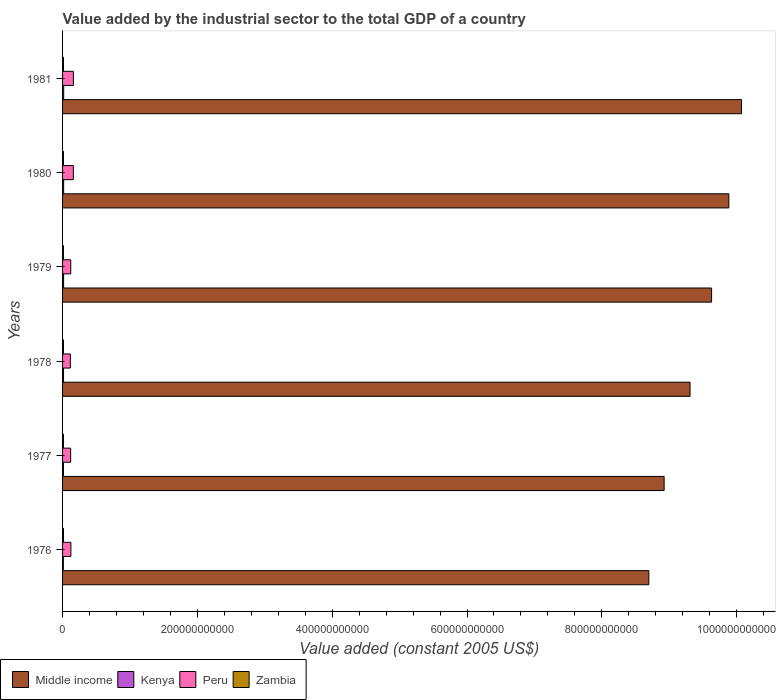How many groups of bars are there?
Ensure brevity in your answer.  6. Are the number of bars on each tick of the Y-axis equal?
Your response must be concise. Yes. What is the label of the 3rd group of bars from the top?
Your answer should be very brief. 1979. In how many cases, is the number of bars for a given year not equal to the number of legend labels?
Provide a short and direct response. 0. What is the value added by the industrial sector in Middle income in 1976?
Ensure brevity in your answer.  8.70e+11. Across all years, what is the maximum value added by the industrial sector in Kenya?
Ensure brevity in your answer.  1.66e+09. Across all years, what is the minimum value added by the industrial sector in Peru?
Give a very brief answer. 1.15e+1. In which year was the value added by the industrial sector in Kenya maximum?
Offer a very short reply. 1981. In which year was the value added by the industrial sector in Peru minimum?
Your answer should be very brief. 1978. What is the total value added by the industrial sector in Kenya in the graph?
Give a very brief answer. 8.73e+09. What is the difference between the value added by the industrial sector in Kenya in 1976 and that in 1981?
Your answer should be compact. -4.87e+08. What is the difference between the value added by the industrial sector in Middle income in 1980 and the value added by the industrial sector in Zambia in 1977?
Provide a succinct answer. 9.87e+11. What is the average value added by the industrial sector in Zambia per year?
Keep it short and to the point. 1.33e+09. In the year 1977, what is the difference between the value added by the industrial sector in Kenya and value added by the industrial sector in Middle income?
Provide a short and direct response. -8.91e+11. In how many years, is the value added by the industrial sector in Middle income greater than 80000000000 US$?
Ensure brevity in your answer.  6. What is the ratio of the value added by the industrial sector in Kenya in 1977 to that in 1981?
Keep it short and to the point. 0.8. What is the difference between the highest and the second highest value added by the industrial sector in Peru?
Provide a succinct answer. 1.73e+07. What is the difference between the highest and the lowest value added by the industrial sector in Peru?
Provide a short and direct response. 4.49e+09. Is the sum of the value added by the industrial sector in Middle income in 1978 and 1980 greater than the maximum value added by the industrial sector in Peru across all years?
Keep it short and to the point. Yes. Is it the case that in every year, the sum of the value added by the industrial sector in Peru and value added by the industrial sector in Zambia is greater than the sum of value added by the industrial sector in Kenya and value added by the industrial sector in Middle income?
Your answer should be very brief. No. What does the 3rd bar from the bottom in 1980 represents?
Give a very brief answer. Peru. Is it the case that in every year, the sum of the value added by the industrial sector in Kenya and value added by the industrial sector in Zambia is greater than the value added by the industrial sector in Middle income?
Keep it short and to the point. No. How many bars are there?
Your response must be concise. 24. Are all the bars in the graph horizontal?
Make the answer very short. Yes. What is the difference between two consecutive major ticks on the X-axis?
Ensure brevity in your answer.  2.00e+11. Are the values on the major ticks of X-axis written in scientific E-notation?
Provide a succinct answer. No. Does the graph contain grids?
Offer a terse response. No. How many legend labels are there?
Make the answer very short. 4. What is the title of the graph?
Your answer should be very brief. Value added by the industrial sector to the total GDP of a country. What is the label or title of the X-axis?
Provide a succinct answer. Value added (constant 2005 US$). What is the label or title of the Y-axis?
Provide a succinct answer. Years. What is the Value added (constant 2005 US$) of Middle income in 1976?
Offer a terse response. 8.70e+11. What is the Value added (constant 2005 US$) of Kenya in 1976?
Provide a succinct answer. 1.17e+09. What is the Value added (constant 2005 US$) of Peru in 1976?
Offer a terse response. 1.24e+1. What is the Value added (constant 2005 US$) of Zambia in 1976?
Provide a succinct answer. 1.38e+09. What is the Value added (constant 2005 US$) in Middle income in 1977?
Offer a very short reply. 8.92e+11. What is the Value added (constant 2005 US$) of Kenya in 1977?
Make the answer very short. 1.32e+09. What is the Value added (constant 2005 US$) of Peru in 1977?
Keep it short and to the point. 1.20e+1. What is the Value added (constant 2005 US$) of Zambia in 1977?
Offer a terse response. 1.29e+09. What is the Value added (constant 2005 US$) in Middle income in 1978?
Ensure brevity in your answer.  9.31e+11. What is the Value added (constant 2005 US$) in Kenya in 1978?
Your answer should be compact. 1.46e+09. What is the Value added (constant 2005 US$) of Peru in 1978?
Provide a succinct answer. 1.15e+1. What is the Value added (constant 2005 US$) of Zambia in 1978?
Make the answer very short. 1.34e+09. What is the Value added (constant 2005 US$) in Middle income in 1979?
Offer a very short reply. 9.63e+11. What is the Value added (constant 2005 US$) of Kenya in 1979?
Offer a terse response. 1.52e+09. What is the Value added (constant 2005 US$) of Peru in 1979?
Give a very brief answer. 1.21e+1. What is the Value added (constant 2005 US$) of Zambia in 1979?
Offer a terse response. 1.28e+09. What is the Value added (constant 2005 US$) of Middle income in 1980?
Ensure brevity in your answer.  9.88e+11. What is the Value added (constant 2005 US$) of Kenya in 1980?
Make the answer very short. 1.60e+09. What is the Value added (constant 2005 US$) in Peru in 1980?
Provide a succinct answer. 1.60e+1. What is the Value added (constant 2005 US$) in Zambia in 1980?
Ensure brevity in your answer.  1.30e+09. What is the Value added (constant 2005 US$) in Middle income in 1981?
Ensure brevity in your answer.  1.01e+12. What is the Value added (constant 2005 US$) in Kenya in 1981?
Your answer should be compact. 1.66e+09. What is the Value added (constant 2005 US$) in Peru in 1981?
Make the answer very short. 1.60e+1. What is the Value added (constant 2005 US$) of Zambia in 1981?
Provide a succinct answer. 1.37e+09. Across all years, what is the maximum Value added (constant 2005 US$) of Middle income?
Keep it short and to the point. 1.01e+12. Across all years, what is the maximum Value added (constant 2005 US$) of Kenya?
Provide a succinct answer. 1.66e+09. Across all years, what is the maximum Value added (constant 2005 US$) of Peru?
Give a very brief answer. 1.60e+1. Across all years, what is the maximum Value added (constant 2005 US$) of Zambia?
Your answer should be compact. 1.38e+09. Across all years, what is the minimum Value added (constant 2005 US$) of Middle income?
Your answer should be compact. 8.70e+11. Across all years, what is the minimum Value added (constant 2005 US$) in Kenya?
Keep it short and to the point. 1.17e+09. Across all years, what is the minimum Value added (constant 2005 US$) of Peru?
Ensure brevity in your answer.  1.15e+1. Across all years, what is the minimum Value added (constant 2005 US$) of Zambia?
Provide a short and direct response. 1.28e+09. What is the total Value added (constant 2005 US$) of Middle income in the graph?
Offer a very short reply. 5.65e+12. What is the total Value added (constant 2005 US$) in Kenya in the graph?
Keep it short and to the point. 8.73e+09. What is the total Value added (constant 2005 US$) in Peru in the graph?
Make the answer very short. 8.01e+1. What is the total Value added (constant 2005 US$) of Zambia in the graph?
Keep it short and to the point. 7.97e+09. What is the difference between the Value added (constant 2005 US$) of Middle income in 1976 and that in 1977?
Offer a terse response. -2.27e+1. What is the difference between the Value added (constant 2005 US$) in Kenya in 1976 and that in 1977?
Your response must be concise. -1.51e+08. What is the difference between the Value added (constant 2005 US$) of Peru in 1976 and that in 1977?
Provide a succinct answer. 3.55e+08. What is the difference between the Value added (constant 2005 US$) of Zambia in 1976 and that in 1977?
Your answer should be very brief. 9.32e+07. What is the difference between the Value added (constant 2005 US$) in Middle income in 1976 and that in 1978?
Make the answer very short. -6.11e+1. What is the difference between the Value added (constant 2005 US$) of Kenya in 1976 and that in 1978?
Make the answer very short. -2.91e+08. What is the difference between the Value added (constant 2005 US$) in Peru in 1976 and that in 1978?
Ensure brevity in your answer.  8.14e+08. What is the difference between the Value added (constant 2005 US$) of Zambia in 1976 and that in 1978?
Ensure brevity in your answer.  3.74e+07. What is the difference between the Value added (constant 2005 US$) in Middle income in 1976 and that in 1979?
Provide a short and direct response. -9.31e+1. What is the difference between the Value added (constant 2005 US$) in Kenya in 1976 and that in 1979?
Ensure brevity in your answer.  -3.43e+08. What is the difference between the Value added (constant 2005 US$) in Peru in 1976 and that in 1979?
Provide a succinct answer. 2.24e+08. What is the difference between the Value added (constant 2005 US$) in Zambia in 1976 and that in 1979?
Give a very brief answer. 1.06e+08. What is the difference between the Value added (constant 2005 US$) in Middle income in 1976 and that in 1980?
Your answer should be compact. -1.19e+11. What is the difference between the Value added (constant 2005 US$) of Kenya in 1976 and that in 1980?
Ensure brevity in your answer.  -4.23e+08. What is the difference between the Value added (constant 2005 US$) of Peru in 1976 and that in 1980?
Your answer should be very brief. -3.66e+09. What is the difference between the Value added (constant 2005 US$) in Zambia in 1976 and that in 1980?
Offer a terse response. 7.72e+07. What is the difference between the Value added (constant 2005 US$) of Middle income in 1976 and that in 1981?
Offer a very short reply. -1.38e+11. What is the difference between the Value added (constant 2005 US$) of Kenya in 1976 and that in 1981?
Your answer should be very brief. -4.87e+08. What is the difference between the Value added (constant 2005 US$) of Peru in 1976 and that in 1981?
Give a very brief answer. -3.67e+09. What is the difference between the Value added (constant 2005 US$) in Zambia in 1976 and that in 1981?
Your answer should be compact. 1.24e+07. What is the difference between the Value added (constant 2005 US$) in Middle income in 1977 and that in 1978?
Make the answer very short. -3.84e+1. What is the difference between the Value added (constant 2005 US$) of Kenya in 1977 and that in 1978?
Ensure brevity in your answer.  -1.40e+08. What is the difference between the Value added (constant 2005 US$) of Peru in 1977 and that in 1978?
Your answer should be very brief. 4.59e+08. What is the difference between the Value added (constant 2005 US$) of Zambia in 1977 and that in 1978?
Your answer should be very brief. -5.58e+07. What is the difference between the Value added (constant 2005 US$) of Middle income in 1977 and that in 1979?
Provide a short and direct response. -7.04e+1. What is the difference between the Value added (constant 2005 US$) in Kenya in 1977 and that in 1979?
Your answer should be very brief. -1.92e+08. What is the difference between the Value added (constant 2005 US$) of Peru in 1977 and that in 1979?
Provide a short and direct response. -1.31e+08. What is the difference between the Value added (constant 2005 US$) of Zambia in 1977 and that in 1979?
Keep it short and to the point. 1.31e+07. What is the difference between the Value added (constant 2005 US$) in Middle income in 1977 and that in 1980?
Offer a very short reply. -9.60e+1. What is the difference between the Value added (constant 2005 US$) in Kenya in 1977 and that in 1980?
Provide a succinct answer. -2.73e+08. What is the difference between the Value added (constant 2005 US$) in Peru in 1977 and that in 1980?
Offer a terse response. -4.01e+09. What is the difference between the Value added (constant 2005 US$) in Zambia in 1977 and that in 1980?
Keep it short and to the point. -1.60e+07. What is the difference between the Value added (constant 2005 US$) of Middle income in 1977 and that in 1981?
Provide a short and direct response. -1.15e+11. What is the difference between the Value added (constant 2005 US$) in Kenya in 1977 and that in 1981?
Your response must be concise. -3.36e+08. What is the difference between the Value added (constant 2005 US$) in Peru in 1977 and that in 1981?
Provide a short and direct response. -4.03e+09. What is the difference between the Value added (constant 2005 US$) of Zambia in 1977 and that in 1981?
Keep it short and to the point. -8.08e+07. What is the difference between the Value added (constant 2005 US$) in Middle income in 1978 and that in 1979?
Make the answer very short. -3.20e+1. What is the difference between the Value added (constant 2005 US$) in Kenya in 1978 and that in 1979?
Offer a very short reply. -5.17e+07. What is the difference between the Value added (constant 2005 US$) in Peru in 1978 and that in 1979?
Offer a terse response. -5.89e+08. What is the difference between the Value added (constant 2005 US$) of Zambia in 1978 and that in 1979?
Provide a succinct answer. 6.89e+07. What is the difference between the Value added (constant 2005 US$) in Middle income in 1978 and that in 1980?
Ensure brevity in your answer.  -5.75e+1. What is the difference between the Value added (constant 2005 US$) in Kenya in 1978 and that in 1980?
Offer a very short reply. -1.33e+08. What is the difference between the Value added (constant 2005 US$) in Peru in 1978 and that in 1980?
Your answer should be very brief. -4.47e+09. What is the difference between the Value added (constant 2005 US$) in Zambia in 1978 and that in 1980?
Keep it short and to the point. 3.98e+07. What is the difference between the Value added (constant 2005 US$) in Middle income in 1978 and that in 1981?
Keep it short and to the point. -7.64e+1. What is the difference between the Value added (constant 2005 US$) of Kenya in 1978 and that in 1981?
Your answer should be very brief. -1.96e+08. What is the difference between the Value added (constant 2005 US$) in Peru in 1978 and that in 1981?
Keep it short and to the point. -4.49e+09. What is the difference between the Value added (constant 2005 US$) of Zambia in 1978 and that in 1981?
Your answer should be very brief. -2.50e+07. What is the difference between the Value added (constant 2005 US$) in Middle income in 1979 and that in 1980?
Provide a short and direct response. -2.56e+1. What is the difference between the Value added (constant 2005 US$) of Kenya in 1979 and that in 1980?
Provide a succinct answer. -8.08e+07. What is the difference between the Value added (constant 2005 US$) in Peru in 1979 and that in 1980?
Ensure brevity in your answer.  -3.88e+09. What is the difference between the Value added (constant 2005 US$) of Zambia in 1979 and that in 1980?
Offer a terse response. -2.91e+07. What is the difference between the Value added (constant 2005 US$) in Middle income in 1979 and that in 1981?
Give a very brief answer. -4.44e+1. What is the difference between the Value added (constant 2005 US$) in Kenya in 1979 and that in 1981?
Provide a succinct answer. -1.45e+08. What is the difference between the Value added (constant 2005 US$) in Peru in 1979 and that in 1981?
Make the answer very short. -3.90e+09. What is the difference between the Value added (constant 2005 US$) in Zambia in 1979 and that in 1981?
Provide a succinct answer. -9.39e+07. What is the difference between the Value added (constant 2005 US$) of Middle income in 1980 and that in 1981?
Provide a succinct answer. -1.89e+1. What is the difference between the Value added (constant 2005 US$) of Kenya in 1980 and that in 1981?
Provide a short and direct response. -6.39e+07. What is the difference between the Value added (constant 2005 US$) in Peru in 1980 and that in 1981?
Provide a succinct answer. -1.73e+07. What is the difference between the Value added (constant 2005 US$) in Zambia in 1980 and that in 1981?
Your answer should be very brief. -6.48e+07. What is the difference between the Value added (constant 2005 US$) of Middle income in 1976 and the Value added (constant 2005 US$) of Kenya in 1977?
Ensure brevity in your answer.  8.68e+11. What is the difference between the Value added (constant 2005 US$) of Middle income in 1976 and the Value added (constant 2005 US$) of Peru in 1977?
Ensure brevity in your answer.  8.58e+11. What is the difference between the Value added (constant 2005 US$) of Middle income in 1976 and the Value added (constant 2005 US$) of Zambia in 1977?
Provide a short and direct response. 8.68e+11. What is the difference between the Value added (constant 2005 US$) of Kenya in 1976 and the Value added (constant 2005 US$) of Peru in 1977?
Provide a succinct answer. -1.08e+1. What is the difference between the Value added (constant 2005 US$) of Kenya in 1976 and the Value added (constant 2005 US$) of Zambia in 1977?
Ensure brevity in your answer.  -1.16e+08. What is the difference between the Value added (constant 2005 US$) in Peru in 1976 and the Value added (constant 2005 US$) in Zambia in 1977?
Offer a very short reply. 1.11e+1. What is the difference between the Value added (constant 2005 US$) of Middle income in 1976 and the Value added (constant 2005 US$) of Kenya in 1978?
Make the answer very short. 8.68e+11. What is the difference between the Value added (constant 2005 US$) in Middle income in 1976 and the Value added (constant 2005 US$) in Peru in 1978?
Provide a succinct answer. 8.58e+11. What is the difference between the Value added (constant 2005 US$) in Middle income in 1976 and the Value added (constant 2005 US$) in Zambia in 1978?
Your response must be concise. 8.68e+11. What is the difference between the Value added (constant 2005 US$) of Kenya in 1976 and the Value added (constant 2005 US$) of Peru in 1978?
Offer a very short reply. -1.04e+1. What is the difference between the Value added (constant 2005 US$) in Kenya in 1976 and the Value added (constant 2005 US$) in Zambia in 1978?
Make the answer very short. -1.71e+08. What is the difference between the Value added (constant 2005 US$) of Peru in 1976 and the Value added (constant 2005 US$) of Zambia in 1978?
Keep it short and to the point. 1.10e+1. What is the difference between the Value added (constant 2005 US$) of Middle income in 1976 and the Value added (constant 2005 US$) of Kenya in 1979?
Your answer should be very brief. 8.68e+11. What is the difference between the Value added (constant 2005 US$) of Middle income in 1976 and the Value added (constant 2005 US$) of Peru in 1979?
Offer a very short reply. 8.58e+11. What is the difference between the Value added (constant 2005 US$) of Middle income in 1976 and the Value added (constant 2005 US$) of Zambia in 1979?
Ensure brevity in your answer.  8.68e+11. What is the difference between the Value added (constant 2005 US$) of Kenya in 1976 and the Value added (constant 2005 US$) of Peru in 1979?
Provide a succinct answer. -1.10e+1. What is the difference between the Value added (constant 2005 US$) of Kenya in 1976 and the Value added (constant 2005 US$) of Zambia in 1979?
Your answer should be compact. -1.03e+08. What is the difference between the Value added (constant 2005 US$) in Peru in 1976 and the Value added (constant 2005 US$) in Zambia in 1979?
Provide a short and direct response. 1.11e+1. What is the difference between the Value added (constant 2005 US$) of Middle income in 1976 and the Value added (constant 2005 US$) of Kenya in 1980?
Your response must be concise. 8.68e+11. What is the difference between the Value added (constant 2005 US$) of Middle income in 1976 and the Value added (constant 2005 US$) of Peru in 1980?
Provide a succinct answer. 8.54e+11. What is the difference between the Value added (constant 2005 US$) in Middle income in 1976 and the Value added (constant 2005 US$) in Zambia in 1980?
Make the answer very short. 8.68e+11. What is the difference between the Value added (constant 2005 US$) of Kenya in 1976 and the Value added (constant 2005 US$) of Peru in 1980?
Offer a very short reply. -1.48e+1. What is the difference between the Value added (constant 2005 US$) in Kenya in 1976 and the Value added (constant 2005 US$) in Zambia in 1980?
Make the answer very short. -1.32e+08. What is the difference between the Value added (constant 2005 US$) of Peru in 1976 and the Value added (constant 2005 US$) of Zambia in 1980?
Keep it short and to the point. 1.11e+1. What is the difference between the Value added (constant 2005 US$) in Middle income in 1976 and the Value added (constant 2005 US$) in Kenya in 1981?
Your answer should be compact. 8.68e+11. What is the difference between the Value added (constant 2005 US$) of Middle income in 1976 and the Value added (constant 2005 US$) of Peru in 1981?
Offer a terse response. 8.54e+11. What is the difference between the Value added (constant 2005 US$) in Middle income in 1976 and the Value added (constant 2005 US$) in Zambia in 1981?
Ensure brevity in your answer.  8.68e+11. What is the difference between the Value added (constant 2005 US$) in Kenya in 1976 and the Value added (constant 2005 US$) in Peru in 1981?
Ensure brevity in your answer.  -1.49e+1. What is the difference between the Value added (constant 2005 US$) in Kenya in 1976 and the Value added (constant 2005 US$) in Zambia in 1981?
Offer a terse response. -1.96e+08. What is the difference between the Value added (constant 2005 US$) in Peru in 1976 and the Value added (constant 2005 US$) in Zambia in 1981?
Your answer should be very brief. 1.10e+1. What is the difference between the Value added (constant 2005 US$) of Middle income in 1977 and the Value added (constant 2005 US$) of Kenya in 1978?
Offer a terse response. 8.91e+11. What is the difference between the Value added (constant 2005 US$) of Middle income in 1977 and the Value added (constant 2005 US$) of Peru in 1978?
Offer a very short reply. 8.81e+11. What is the difference between the Value added (constant 2005 US$) in Middle income in 1977 and the Value added (constant 2005 US$) in Zambia in 1978?
Ensure brevity in your answer.  8.91e+11. What is the difference between the Value added (constant 2005 US$) of Kenya in 1977 and the Value added (constant 2005 US$) of Peru in 1978?
Offer a terse response. -1.02e+1. What is the difference between the Value added (constant 2005 US$) of Kenya in 1977 and the Value added (constant 2005 US$) of Zambia in 1978?
Your answer should be very brief. -2.07e+07. What is the difference between the Value added (constant 2005 US$) of Peru in 1977 and the Value added (constant 2005 US$) of Zambia in 1978?
Offer a very short reply. 1.07e+1. What is the difference between the Value added (constant 2005 US$) in Middle income in 1977 and the Value added (constant 2005 US$) in Kenya in 1979?
Provide a short and direct response. 8.91e+11. What is the difference between the Value added (constant 2005 US$) of Middle income in 1977 and the Value added (constant 2005 US$) of Peru in 1979?
Offer a terse response. 8.80e+11. What is the difference between the Value added (constant 2005 US$) of Middle income in 1977 and the Value added (constant 2005 US$) of Zambia in 1979?
Keep it short and to the point. 8.91e+11. What is the difference between the Value added (constant 2005 US$) in Kenya in 1977 and the Value added (constant 2005 US$) in Peru in 1979?
Give a very brief answer. -1.08e+1. What is the difference between the Value added (constant 2005 US$) in Kenya in 1977 and the Value added (constant 2005 US$) in Zambia in 1979?
Your answer should be very brief. 4.82e+07. What is the difference between the Value added (constant 2005 US$) of Peru in 1977 and the Value added (constant 2005 US$) of Zambia in 1979?
Offer a terse response. 1.07e+1. What is the difference between the Value added (constant 2005 US$) of Middle income in 1977 and the Value added (constant 2005 US$) of Kenya in 1980?
Your response must be concise. 8.91e+11. What is the difference between the Value added (constant 2005 US$) in Middle income in 1977 and the Value added (constant 2005 US$) in Peru in 1980?
Offer a terse response. 8.76e+11. What is the difference between the Value added (constant 2005 US$) of Middle income in 1977 and the Value added (constant 2005 US$) of Zambia in 1980?
Offer a terse response. 8.91e+11. What is the difference between the Value added (constant 2005 US$) in Kenya in 1977 and the Value added (constant 2005 US$) in Peru in 1980?
Your answer should be compact. -1.47e+1. What is the difference between the Value added (constant 2005 US$) in Kenya in 1977 and the Value added (constant 2005 US$) in Zambia in 1980?
Your answer should be compact. 1.91e+07. What is the difference between the Value added (constant 2005 US$) of Peru in 1977 and the Value added (constant 2005 US$) of Zambia in 1980?
Make the answer very short. 1.07e+1. What is the difference between the Value added (constant 2005 US$) in Middle income in 1977 and the Value added (constant 2005 US$) in Kenya in 1981?
Your response must be concise. 8.91e+11. What is the difference between the Value added (constant 2005 US$) in Middle income in 1977 and the Value added (constant 2005 US$) in Peru in 1981?
Your answer should be compact. 8.76e+11. What is the difference between the Value added (constant 2005 US$) of Middle income in 1977 and the Value added (constant 2005 US$) of Zambia in 1981?
Provide a succinct answer. 8.91e+11. What is the difference between the Value added (constant 2005 US$) of Kenya in 1977 and the Value added (constant 2005 US$) of Peru in 1981?
Make the answer very short. -1.47e+1. What is the difference between the Value added (constant 2005 US$) in Kenya in 1977 and the Value added (constant 2005 US$) in Zambia in 1981?
Provide a short and direct response. -4.57e+07. What is the difference between the Value added (constant 2005 US$) in Peru in 1977 and the Value added (constant 2005 US$) in Zambia in 1981?
Offer a terse response. 1.06e+1. What is the difference between the Value added (constant 2005 US$) of Middle income in 1978 and the Value added (constant 2005 US$) of Kenya in 1979?
Ensure brevity in your answer.  9.29e+11. What is the difference between the Value added (constant 2005 US$) of Middle income in 1978 and the Value added (constant 2005 US$) of Peru in 1979?
Your answer should be compact. 9.19e+11. What is the difference between the Value added (constant 2005 US$) of Middle income in 1978 and the Value added (constant 2005 US$) of Zambia in 1979?
Keep it short and to the point. 9.30e+11. What is the difference between the Value added (constant 2005 US$) of Kenya in 1978 and the Value added (constant 2005 US$) of Peru in 1979?
Your answer should be compact. -1.07e+1. What is the difference between the Value added (constant 2005 US$) of Kenya in 1978 and the Value added (constant 2005 US$) of Zambia in 1979?
Provide a short and direct response. 1.88e+08. What is the difference between the Value added (constant 2005 US$) in Peru in 1978 and the Value added (constant 2005 US$) in Zambia in 1979?
Keep it short and to the point. 1.03e+1. What is the difference between the Value added (constant 2005 US$) in Middle income in 1978 and the Value added (constant 2005 US$) in Kenya in 1980?
Your answer should be very brief. 9.29e+11. What is the difference between the Value added (constant 2005 US$) of Middle income in 1978 and the Value added (constant 2005 US$) of Peru in 1980?
Keep it short and to the point. 9.15e+11. What is the difference between the Value added (constant 2005 US$) in Middle income in 1978 and the Value added (constant 2005 US$) in Zambia in 1980?
Offer a terse response. 9.30e+11. What is the difference between the Value added (constant 2005 US$) of Kenya in 1978 and the Value added (constant 2005 US$) of Peru in 1980?
Keep it short and to the point. -1.45e+1. What is the difference between the Value added (constant 2005 US$) of Kenya in 1978 and the Value added (constant 2005 US$) of Zambia in 1980?
Ensure brevity in your answer.  1.59e+08. What is the difference between the Value added (constant 2005 US$) of Peru in 1978 and the Value added (constant 2005 US$) of Zambia in 1980?
Give a very brief answer. 1.02e+1. What is the difference between the Value added (constant 2005 US$) in Middle income in 1978 and the Value added (constant 2005 US$) in Kenya in 1981?
Offer a terse response. 9.29e+11. What is the difference between the Value added (constant 2005 US$) in Middle income in 1978 and the Value added (constant 2005 US$) in Peru in 1981?
Provide a succinct answer. 9.15e+11. What is the difference between the Value added (constant 2005 US$) of Middle income in 1978 and the Value added (constant 2005 US$) of Zambia in 1981?
Provide a succinct answer. 9.30e+11. What is the difference between the Value added (constant 2005 US$) in Kenya in 1978 and the Value added (constant 2005 US$) in Peru in 1981?
Make the answer very short. -1.46e+1. What is the difference between the Value added (constant 2005 US$) of Kenya in 1978 and the Value added (constant 2005 US$) of Zambia in 1981?
Give a very brief answer. 9.43e+07. What is the difference between the Value added (constant 2005 US$) in Peru in 1978 and the Value added (constant 2005 US$) in Zambia in 1981?
Provide a short and direct response. 1.02e+1. What is the difference between the Value added (constant 2005 US$) of Middle income in 1979 and the Value added (constant 2005 US$) of Kenya in 1980?
Give a very brief answer. 9.61e+11. What is the difference between the Value added (constant 2005 US$) in Middle income in 1979 and the Value added (constant 2005 US$) in Peru in 1980?
Offer a very short reply. 9.47e+11. What is the difference between the Value added (constant 2005 US$) in Middle income in 1979 and the Value added (constant 2005 US$) in Zambia in 1980?
Your answer should be very brief. 9.62e+11. What is the difference between the Value added (constant 2005 US$) in Kenya in 1979 and the Value added (constant 2005 US$) in Peru in 1980?
Keep it short and to the point. -1.45e+1. What is the difference between the Value added (constant 2005 US$) in Kenya in 1979 and the Value added (constant 2005 US$) in Zambia in 1980?
Make the answer very short. 2.11e+08. What is the difference between the Value added (constant 2005 US$) in Peru in 1979 and the Value added (constant 2005 US$) in Zambia in 1980?
Your answer should be compact. 1.08e+1. What is the difference between the Value added (constant 2005 US$) of Middle income in 1979 and the Value added (constant 2005 US$) of Kenya in 1981?
Make the answer very short. 9.61e+11. What is the difference between the Value added (constant 2005 US$) in Middle income in 1979 and the Value added (constant 2005 US$) in Peru in 1981?
Your response must be concise. 9.47e+11. What is the difference between the Value added (constant 2005 US$) in Middle income in 1979 and the Value added (constant 2005 US$) in Zambia in 1981?
Your response must be concise. 9.61e+11. What is the difference between the Value added (constant 2005 US$) of Kenya in 1979 and the Value added (constant 2005 US$) of Peru in 1981?
Give a very brief answer. -1.45e+1. What is the difference between the Value added (constant 2005 US$) in Kenya in 1979 and the Value added (constant 2005 US$) in Zambia in 1981?
Provide a succinct answer. 1.46e+08. What is the difference between the Value added (constant 2005 US$) in Peru in 1979 and the Value added (constant 2005 US$) in Zambia in 1981?
Give a very brief answer. 1.08e+1. What is the difference between the Value added (constant 2005 US$) in Middle income in 1980 and the Value added (constant 2005 US$) in Kenya in 1981?
Ensure brevity in your answer.  9.87e+11. What is the difference between the Value added (constant 2005 US$) in Middle income in 1980 and the Value added (constant 2005 US$) in Peru in 1981?
Ensure brevity in your answer.  9.72e+11. What is the difference between the Value added (constant 2005 US$) in Middle income in 1980 and the Value added (constant 2005 US$) in Zambia in 1981?
Your response must be concise. 9.87e+11. What is the difference between the Value added (constant 2005 US$) in Kenya in 1980 and the Value added (constant 2005 US$) in Peru in 1981?
Offer a very short reply. -1.44e+1. What is the difference between the Value added (constant 2005 US$) in Kenya in 1980 and the Value added (constant 2005 US$) in Zambia in 1981?
Give a very brief answer. 2.27e+08. What is the difference between the Value added (constant 2005 US$) of Peru in 1980 and the Value added (constant 2005 US$) of Zambia in 1981?
Keep it short and to the point. 1.46e+1. What is the average Value added (constant 2005 US$) of Middle income per year?
Your response must be concise. 9.42e+11. What is the average Value added (constant 2005 US$) in Kenya per year?
Offer a very short reply. 1.46e+09. What is the average Value added (constant 2005 US$) of Peru per year?
Your response must be concise. 1.33e+1. What is the average Value added (constant 2005 US$) of Zambia per year?
Give a very brief answer. 1.33e+09. In the year 1976, what is the difference between the Value added (constant 2005 US$) of Middle income and Value added (constant 2005 US$) of Kenya?
Ensure brevity in your answer.  8.69e+11. In the year 1976, what is the difference between the Value added (constant 2005 US$) of Middle income and Value added (constant 2005 US$) of Peru?
Your response must be concise. 8.57e+11. In the year 1976, what is the difference between the Value added (constant 2005 US$) in Middle income and Value added (constant 2005 US$) in Zambia?
Give a very brief answer. 8.68e+11. In the year 1976, what is the difference between the Value added (constant 2005 US$) in Kenya and Value added (constant 2005 US$) in Peru?
Your response must be concise. -1.12e+1. In the year 1976, what is the difference between the Value added (constant 2005 US$) of Kenya and Value added (constant 2005 US$) of Zambia?
Give a very brief answer. -2.09e+08. In the year 1976, what is the difference between the Value added (constant 2005 US$) in Peru and Value added (constant 2005 US$) in Zambia?
Offer a terse response. 1.10e+1. In the year 1977, what is the difference between the Value added (constant 2005 US$) in Middle income and Value added (constant 2005 US$) in Kenya?
Provide a succinct answer. 8.91e+11. In the year 1977, what is the difference between the Value added (constant 2005 US$) of Middle income and Value added (constant 2005 US$) of Peru?
Keep it short and to the point. 8.80e+11. In the year 1977, what is the difference between the Value added (constant 2005 US$) in Middle income and Value added (constant 2005 US$) in Zambia?
Offer a very short reply. 8.91e+11. In the year 1977, what is the difference between the Value added (constant 2005 US$) of Kenya and Value added (constant 2005 US$) of Peru?
Your response must be concise. -1.07e+1. In the year 1977, what is the difference between the Value added (constant 2005 US$) of Kenya and Value added (constant 2005 US$) of Zambia?
Offer a very short reply. 3.51e+07. In the year 1977, what is the difference between the Value added (constant 2005 US$) in Peru and Value added (constant 2005 US$) in Zambia?
Give a very brief answer. 1.07e+1. In the year 1978, what is the difference between the Value added (constant 2005 US$) of Middle income and Value added (constant 2005 US$) of Kenya?
Offer a terse response. 9.29e+11. In the year 1978, what is the difference between the Value added (constant 2005 US$) in Middle income and Value added (constant 2005 US$) in Peru?
Provide a short and direct response. 9.19e+11. In the year 1978, what is the difference between the Value added (constant 2005 US$) of Middle income and Value added (constant 2005 US$) of Zambia?
Ensure brevity in your answer.  9.30e+11. In the year 1978, what is the difference between the Value added (constant 2005 US$) of Kenya and Value added (constant 2005 US$) of Peru?
Your answer should be very brief. -1.01e+1. In the year 1978, what is the difference between the Value added (constant 2005 US$) of Kenya and Value added (constant 2005 US$) of Zambia?
Offer a very short reply. 1.19e+08. In the year 1978, what is the difference between the Value added (constant 2005 US$) in Peru and Value added (constant 2005 US$) in Zambia?
Ensure brevity in your answer.  1.02e+1. In the year 1979, what is the difference between the Value added (constant 2005 US$) in Middle income and Value added (constant 2005 US$) in Kenya?
Give a very brief answer. 9.61e+11. In the year 1979, what is the difference between the Value added (constant 2005 US$) of Middle income and Value added (constant 2005 US$) of Peru?
Give a very brief answer. 9.51e+11. In the year 1979, what is the difference between the Value added (constant 2005 US$) in Middle income and Value added (constant 2005 US$) in Zambia?
Ensure brevity in your answer.  9.62e+11. In the year 1979, what is the difference between the Value added (constant 2005 US$) in Kenya and Value added (constant 2005 US$) in Peru?
Give a very brief answer. -1.06e+1. In the year 1979, what is the difference between the Value added (constant 2005 US$) in Kenya and Value added (constant 2005 US$) in Zambia?
Offer a terse response. 2.40e+08. In the year 1979, what is the difference between the Value added (constant 2005 US$) in Peru and Value added (constant 2005 US$) in Zambia?
Provide a short and direct response. 1.09e+1. In the year 1980, what is the difference between the Value added (constant 2005 US$) of Middle income and Value added (constant 2005 US$) of Kenya?
Your answer should be compact. 9.87e+11. In the year 1980, what is the difference between the Value added (constant 2005 US$) in Middle income and Value added (constant 2005 US$) in Peru?
Provide a succinct answer. 9.72e+11. In the year 1980, what is the difference between the Value added (constant 2005 US$) of Middle income and Value added (constant 2005 US$) of Zambia?
Give a very brief answer. 9.87e+11. In the year 1980, what is the difference between the Value added (constant 2005 US$) in Kenya and Value added (constant 2005 US$) in Peru?
Your answer should be compact. -1.44e+1. In the year 1980, what is the difference between the Value added (constant 2005 US$) in Kenya and Value added (constant 2005 US$) in Zambia?
Ensure brevity in your answer.  2.92e+08. In the year 1980, what is the difference between the Value added (constant 2005 US$) in Peru and Value added (constant 2005 US$) in Zambia?
Give a very brief answer. 1.47e+1. In the year 1981, what is the difference between the Value added (constant 2005 US$) in Middle income and Value added (constant 2005 US$) in Kenya?
Your answer should be very brief. 1.01e+12. In the year 1981, what is the difference between the Value added (constant 2005 US$) in Middle income and Value added (constant 2005 US$) in Peru?
Offer a terse response. 9.91e+11. In the year 1981, what is the difference between the Value added (constant 2005 US$) in Middle income and Value added (constant 2005 US$) in Zambia?
Provide a succinct answer. 1.01e+12. In the year 1981, what is the difference between the Value added (constant 2005 US$) of Kenya and Value added (constant 2005 US$) of Peru?
Your answer should be very brief. -1.44e+1. In the year 1981, what is the difference between the Value added (constant 2005 US$) in Kenya and Value added (constant 2005 US$) in Zambia?
Your answer should be very brief. 2.91e+08. In the year 1981, what is the difference between the Value added (constant 2005 US$) in Peru and Value added (constant 2005 US$) in Zambia?
Your response must be concise. 1.47e+1. What is the ratio of the Value added (constant 2005 US$) of Middle income in 1976 to that in 1977?
Provide a short and direct response. 0.97. What is the ratio of the Value added (constant 2005 US$) of Kenya in 1976 to that in 1977?
Provide a succinct answer. 0.89. What is the ratio of the Value added (constant 2005 US$) of Peru in 1976 to that in 1977?
Ensure brevity in your answer.  1.03. What is the ratio of the Value added (constant 2005 US$) of Zambia in 1976 to that in 1977?
Keep it short and to the point. 1.07. What is the ratio of the Value added (constant 2005 US$) in Middle income in 1976 to that in 1978?
Provide a succinct answer. 0.93. What is the ratio of the Value added (constant 2005 US$) of Kenya in 1976 to that in 1978?
Keep it short and to the point. 0.8. What is the ratio of the Value added (constant 2005 US$) of Peru in 1976 to that in 1978?
Give a very brief answer. 1.07. What is the ratio of the Value added (constant 2005 US$) in Zambia in 1976 to that in 1978?
Your answer should be compact. 1.03. What is the ratio of the Value added (constant 2005 US$) of Middle income in 1976 to that in 1979?
Your response must be concise. 0.9. What is the ratio of the Value added (constant 2005 US$) in Kenya in 1976 to that in 1979?
Your answer should be compact. 0.77. What is the ratio of the Value added (constant 2005 US$) in Peru in 1976 to that in 1979?
Your answer should be very brief. 1.02. What is the ratio of the Value added (constant 2005 US$) of Middle income in 1976 to that in 1980?
Provide a short and direct response. 0.88. What is the ratio of the Value added (constant 2005 US$) in Kenya in 1976 to that in 1980?
Provide a short and direct response. 0.73. What is the ratio of the Value added (constant 2005 US$) of Peru in 1976 to that in 1980?
Your answer should be very brief. 0.77. What is the ratio of the Value added (constant 2005 US$) in Zambia in 1976 to that in 1980?
Provide a short and direct response. 1.06. What is the ratio of the Value added (constant 2005 US$) of Middle income in 1976 to that in 1981?
Keep it short and to the point. 0.86. What is the ratio of the Value added (constant 2005 US$) of Kenya in 1976 to that in 1981?
Your answer should be very brief. 0.71. What is the ratio of the Value added (constant 2005 US$) in Peru in 1976 to that in 1981?
Offer a very short reply. 0.77. What is the ratio of the Value added (constant 2005 US$) of Zambia in 1976 to that in 1981?
Make the answer very short. 1.01. What is the ratio of the Value added (constant 2005 US$) in Middle income in 1977 to that in 1978?
Your answer should be compact. 0.96. What is the ratio of the Value added (constant 2005 US$) in Kenya in 1977 to that in 1978?
Keep it short and to the point. 0.9. What is the ratio of the Value added (constant 2005 US$) of Peru in 1977 to that in 1978?
Offer a terse response. 1.04. What is the ratio of the Value added (constant 2005 US$) of Zambia in 1977 to that in 1978?
Offer a terse response. 0.96. What is the ratio of the Value added (constant 2005 US$) of Middle income in 1977 to that in 1979?
Offer a terse response. 0.93. What is the ratio of the Value added (constant 2005 US$) of Kenya in 1977 to that in 1979?
Offer a very short reply. 0.87. What is the ratio of the Value added (constant 2005 US$) in Peru in 1977 to that in 1979?
Make the answer very short. 0.99. What is the ratio of the Value added (constant 2005 US$) in Zambia in 1977 to that in 1979?
Your answer should be compact. 1.01. What is the ratio of the Value added (constant 2005 US$) of Middle income in 1977 to that in 1980?
Your response must be concise. 0.9. What is the ratio of the Value added (constant 2005 US$) in Kenya in 1977 to that in 1980?
Your answer should be very brief. 0.83. What is the ratio of the Value added (constant 2005 US$) in Peru in 1977 to that in 1980?
Ensure brevity in your answer.  0.75. What is the ratio of the Value added (constant 2005 US$) in Zambia in 1977 to that in 1980?
Your answer should be very brief. 0.99. What is the ratio of the Value added (constant 2005 US$) in Middle income in 1977 to that in 1981?
Keep it short and to the point. 0.89. What is the ratio of the Value added (constant 2005 US$) in Kenya in 1977 to that in 1981?
Your answer should be very brief. 0.8. What is the ratio of the Value added (constant 2005 US$) of Peru in 1977 to that in 1981?
Make the answer very short. 0.75. What is the ratio of the Value added (constant 2005 US$) in Zambia in 1977 to that in 1981?
Your answer should be very brief. 0.94. What is the ratio of the Value added (constant 2005 US$) in Middle income in 1978 to that in 1979?
Make the answer very short. 0.97. What is the ratio of the Value added (constant 2005 US$) in Kenya in 1978 to that in 1979?
Provide a succinct answer. 0.97. What is the ratio of the Value added (constant 2005 US$) in Peru in 1978 to that in 1979?
Make the answer very short. 0.95. What is the ratio of the Value added (constant 2005 US$) in Zambia in 1978 to that in 1979?
Your response must be concise. 1.05. What is the ratio of the Value added (constant 2005 US$) of Middle income in 1978 to that in 1980?
Provide a short and direct response. 0.94. What is the ratio of the Value added (constant 2005 US$) in Kenya in 1978 to that in 1980?
Ensure brevity in your answer.  0.92. What is the ratio of the Value added (constant 2005 US$) of Peru in 1978 to that in 1980?
Provide a short and direct response. 0.72. What is the ratio of the Value added (constant 2005 US$) of Zambia in 1978 to that in 1980?
Offer a very short reply. 1.03. What is the ratio of the Value added (constant 2005 US$) of Middle income in 1978 to that in 1981?
Offer a terse response. 0.92. What is the ratio of the Value added (constant 2005 US$) in Kenya in 1978 to that in 1981?
Keep it short and to the point. 0.88. What is the ratio of the Value added (constant 2005 US$) in Peru in 1978 to that in 1981?
Offer a very short reply. 0.72. What is the ratio of the Value added (constant 2005 US$) of Zambia in 1978 to that in 1981?
Ensure brevity in your answer.  0.98. What is the ratio of the Value added (constant 2005 US$) in Middle income in 1979 to that in 1980?
Your response must be concise. 0.97. What is the ratio of the Value added (constant 2005 US$) of Kenya in 1979 to that in 1980?
Offer a terse response. 0.95. What is the ratio of the Value added (constant 2005 US$) in Peru in 1979 to that in 1980?
Offer a terse response. 0.76. What is the ratio of the Value added (constant 2005 US$) of Zambia in 1979 to that in 1980?
Offer a terse response. 0.98. What is the ratio of the Value added (constant 2005 US$) of Middle income in 1979 to that in 1981?
Provide a succinct answer. 0.96. What is the ratio of the Value added (constant 2005 US$) in Kenya in 1979 to that in 1981?
Your answer should be very brief. 0.91. What is the ratio of the Value added (constant 2005 US$) in Peru in 1979 to that in 1981?
Provide a succinct answer. 0.76. What is the ratio of the Value added (constant 2005 US$) in Zambia in 1979 to that in 1981?
Your answer should be compact. 0.93. What is the ratio of the Value added (constant 2005 US$) in Middle income in 1980 to that in 1981?
Your answer should be compact. 0.98. What is the ratio of the Value added (constant 2005 US$) of Kenya in 1980 to that in 1981?
Offer a terse response. 0.96. What is the ratio of the Value added (constant 2005 US$) of Zambia in 1980 to that in 1981?
Your answer should be compact. 0.95. What is the difference between the highest and the second highest Value added (constant 2005 US$) in Middle income?
Offer a terse response. 1.89e+1. What is the difference between the highest and the second highest Value added (constant 2005 US$) in Kenya?
Ensure brevity in your answer.  6.39e+07. What is the difference between the highest and the second highest Value added (constant 2005 US$) in Peru?
Your answer should be compact. 1.73e+07. What is the difference between the highest and the second highest Value added (constant 2005 US$) of Zambia?
Offer a terse response. 1.24e+07. What is the difference between the highest and the lowest Value added (constant 2005 US$) in Middle income?
Offer a terse response. 1.38e+11. What is the difference between the highest and the lowest Value added (constant 2005 US$) in Kenya?
Provide a short and direct response. 4.87e+08. What is the difference between the highest and the lowest Value added (constant 2005 US$) of Peru?
Give a very brief answer. 4.49e+09. What is the difference between the highest and the lowest Value added (constant 2005 US$) in Zambia?
Give a very brief answer. 1.06e+08. 